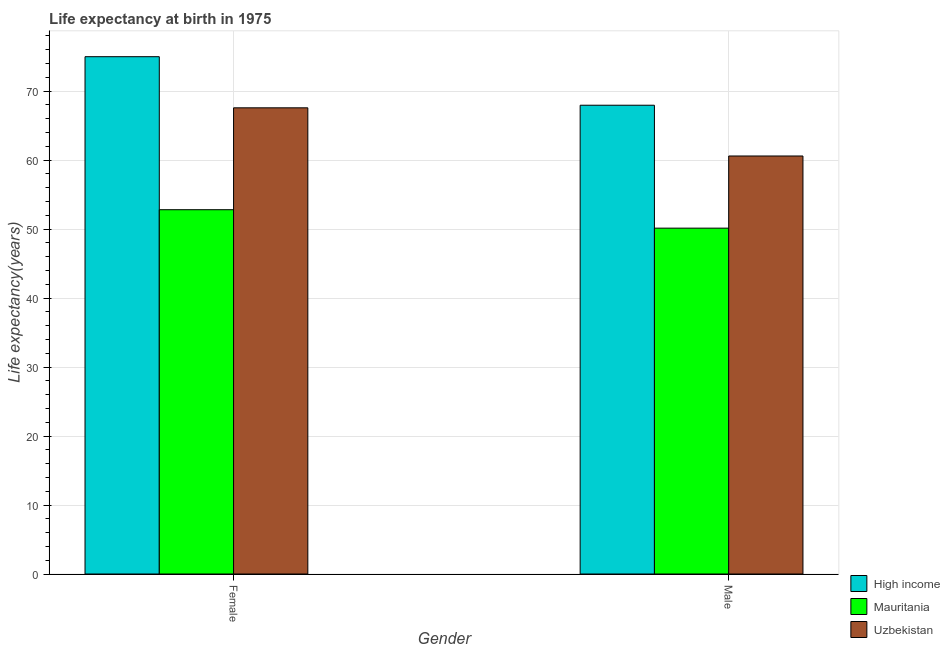How many different coloured bars are there?
Make the answer very short. 3. How many groups of bars are there?
Your answer should be very brief. 2. Are the number of bars per tick equal to the number of legend labels?
Your answer should be compact. Yes. How many bars are there on the 2nd tick from the left?
Your answer should be very brief. 3. What is the life expectancy(female) in Uzbekistan?
Your response must be concise. 67.56. Across all countries, what is the maximum life expectancy(male)?
Ensure brevity in your answer.  67.94. Across all countries, what is the minimum life expectancy(female)?
Provide a succinct answer. 52.8. In which country was the life expectancy(male) maximum?
Your answer should be compact. High income. In which country was the life expectancy(male) minimum?
Your response must be concise. Mauritania. What is the total life expectancy(female) in the graph?
Make the answer very short. 195.33. What is the difference between the life expectancy(female) in Mauritania and that in Uzbekistan?
Ensure brevity in your answer.  -14.77. What is the difference between the life expectancy(female) in High income and the life expectancy(male) in Mauritania?
Your response must be concise. 24.85. What is the average life expectancy(male) per country?
Offer a very short reply. 59.55. What is the difference between the life expectancy(male) and life expectancy(female) in Uzbekistan?
Give a very brief answer. -6.98. What is the ratio of the life expectancy(female) in High income to that in Uzbekistan?
Your answer should be compact. 1.11. In how many countries, is the life expectancy(male) greater than the average life expectancy(male) taken over all countries?
Keep it short and to the point. 2. What does the 2nd bar from the right in Female represents?
Your answer should be very brief. Mauritania. Are all the bars in the graph horizontal?
Offer a very short reply. No. Are the values on the major ticks of Y-axis written in scientific E-notation?
Your answer should be compact. No. Does the graph contain any zero values?
Keep it short and to the point. No. Does the graph contain grids?
Provide a short and direct response. Yes. Where does the legend appear in the graph?
Give a very brief answer. Bottom right. How are the legend labels stacked?
Provide a short and direct response. Vertical. What is the title of the graph?
Ensure brevity in your answer.  Life expectancy at birth in 1975. Does "Azerbaijan" appear as one of the legend labels in the graph?
Provide a short and direct response. No. What is the label or title of the Y-axis?
Ensure brevity in your answer.  Life expectancy(years). What is the Life expectancy(years) in High income in Female?
Offer a very short reply. 74.97. What is the Life expectancy(years) in Mauritania in Female?
Provide a short and direct response. 52.8. What is the Life expectancy(years) of Uzbekistan in Female?
Offer a terse response. 67.56. What is the Life expectancy(years) in High income in Male?
Make the answer very short. 67.94. What is the Life expectancy(years) of Mauritania in Male?
Offer a terse response. 50.12. What is the Life expectancy(years) in Uzbekistan in Male?
Keep it short and to the point. 60.58. Across all Gender, what is the maximum Life expectancy(years) of High income?
Provide a succinct answer. 74.97. Across all Gender, what is the maximum Life expectancy(years) of Mauritania?
Your answer should be very brief. 52.8. Across all Gender, what is the maximum Life expectancy(years) of Uzbekistan?
Keep it short and to the point. 67.56. Across all Gender, what is the minimum Life expectancy(years) in High income?
Offer a very short reply. 67.94. Across all Gender, what is the minimum Life expectancy(years) in Mauritania?
Offer a very short reply. 50.12. Across all Gender, what is the minimum Life expectancy(years) in Uzbekistan?
Your answer should be compact. 60.58. What is the total Life expectancy(years) in High income in the graph?
Give a very brief answer. 142.91. What is the total Life expectancy(years) of Mauritania in the graph?
Provide a succinct answer. 102.92. What is the total Life expectancy(years) in Uzbekistan in the graph?
Ensure brevity in your answer.  128.15. What is the difference between the Life expectancy(years) in High income in Female and that in Male?
Provide a succinct answer. 7.03. What is the difference between the Life expectancy(years) of Mauritania in Female and that in Male?
Your response must be concise. 2.67. What is the difference between the Life expectancy(years) in Uzbekistan in Female and that in Male?
Ensure brevity in your answer.  6.98. What is the difference between the Life expectancy(years) of High income in Female and the Life expectancy(years) of Mauritania in Male?
Provide a short and direct response. 24.85. What is the difference between the Life expectancy(years) of High income in Female and the Life expectancy(years) of Uzbekistan in Male?
Offer a terse response. 14.39. What is the difference between the Life expectancy(years) in Mauritania in Female and the Life expectancy(years) in Uzbekistan in Male?
Your answer should be very brief. -7.79. What is the average Life expectancy(years) in High income per Gender?
Ensure brevity in your answer.  71.46. What is the average Life expectancy(years) in Mauritania per Gender?
Give a very brief answer. 51.46. What is the average Life expectancy(years) in Uzbekistan per Gender?
Keep it short and to the point. 64.07. What is the difference between the Life expectancy(years) of High income and Life expectancy(years) of Mauritania in Female?
Your response must be concise. 22.18. What is the difference between the Life expectancy(years) in High income and Life expectancy(years) in Uzbekistan in Female?
Offer a very short reply. 7.41. What is the difference between the Life expectancy(years) of Mauritania and Life expectancy(years) of Uzbekistan in Female?
Offer a very short reply. -14.77. What is the difference between the Life expectancy(years) in High income and Life expectancy(years) in Mauritania in Male?
Offer a very short reply. 17.82. What is the difference between the Life expectancy(years) of High income and Life expectancy(years) of Uzbekistan in Male?
Give a very brief answer. 7.36. What is the difference between the Life expectancy(years) in Mauritania and Life expectancy(years) in Uzbekistan in Male?
Keep it short and to the point. -10.46. What is the ratio of the Life expectancy(years) of High income in Female to that in Male?
Ensure brevity in your answer.  1.1. What is the ratio of the Life expectancy(years) in Mauritania in Female to that in Male?
Offer a terse response. 1.05. What is the ratio of the Life expectancy(years) in Uzbekistan in Female to that in Male?
Your response must be concise. 1.12. What is the difference between the highest and the second highest Life expectancy(years) in High income?
Make the answer very short. 7.03. What is the difference between the highest and the second highest Life expectancy(years) of Mauritania?
Offer a terse response. 2.67. What is the difference between the highest and the second highest Life expectancy(years) of Uzbekistan?
Ensure brevity in your answer.  6.98. What is the difference between the highest and the lowest Life expectancy(years) in High income?
Your response must be concise. 7.03. What is the difference between the highest and the lowest Life expectancy(years) in Mauritania?
Provide a succinct answer. 2.67. What is the difference between the highest and the lowest Life expectancy(years) of Uzbekistan?
Provide a succinct answer. 6.98. 